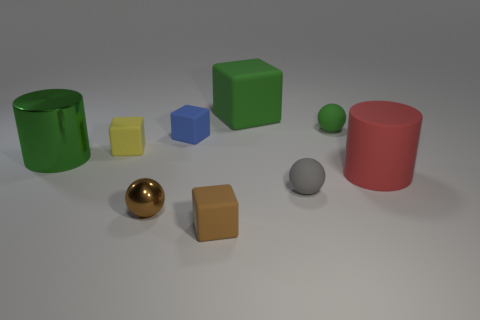Subtract all gray blocks. Subtract all brown cylinders. How many blocks are left? 4 Add 1 brown shiny spheres. How many objects exist? 10 Subtract all balls. How many objects are left? 6 Subtract all large cylinders. Subtract all big green matte cubes. How many objects are left? 6 Add 7 green cylinders. How many green cylinders are left? 8 Add 1 metal cylinders. How many metal cylinders exist? 2 Subtract 0 gray cylinders. How many objects are left? 9 